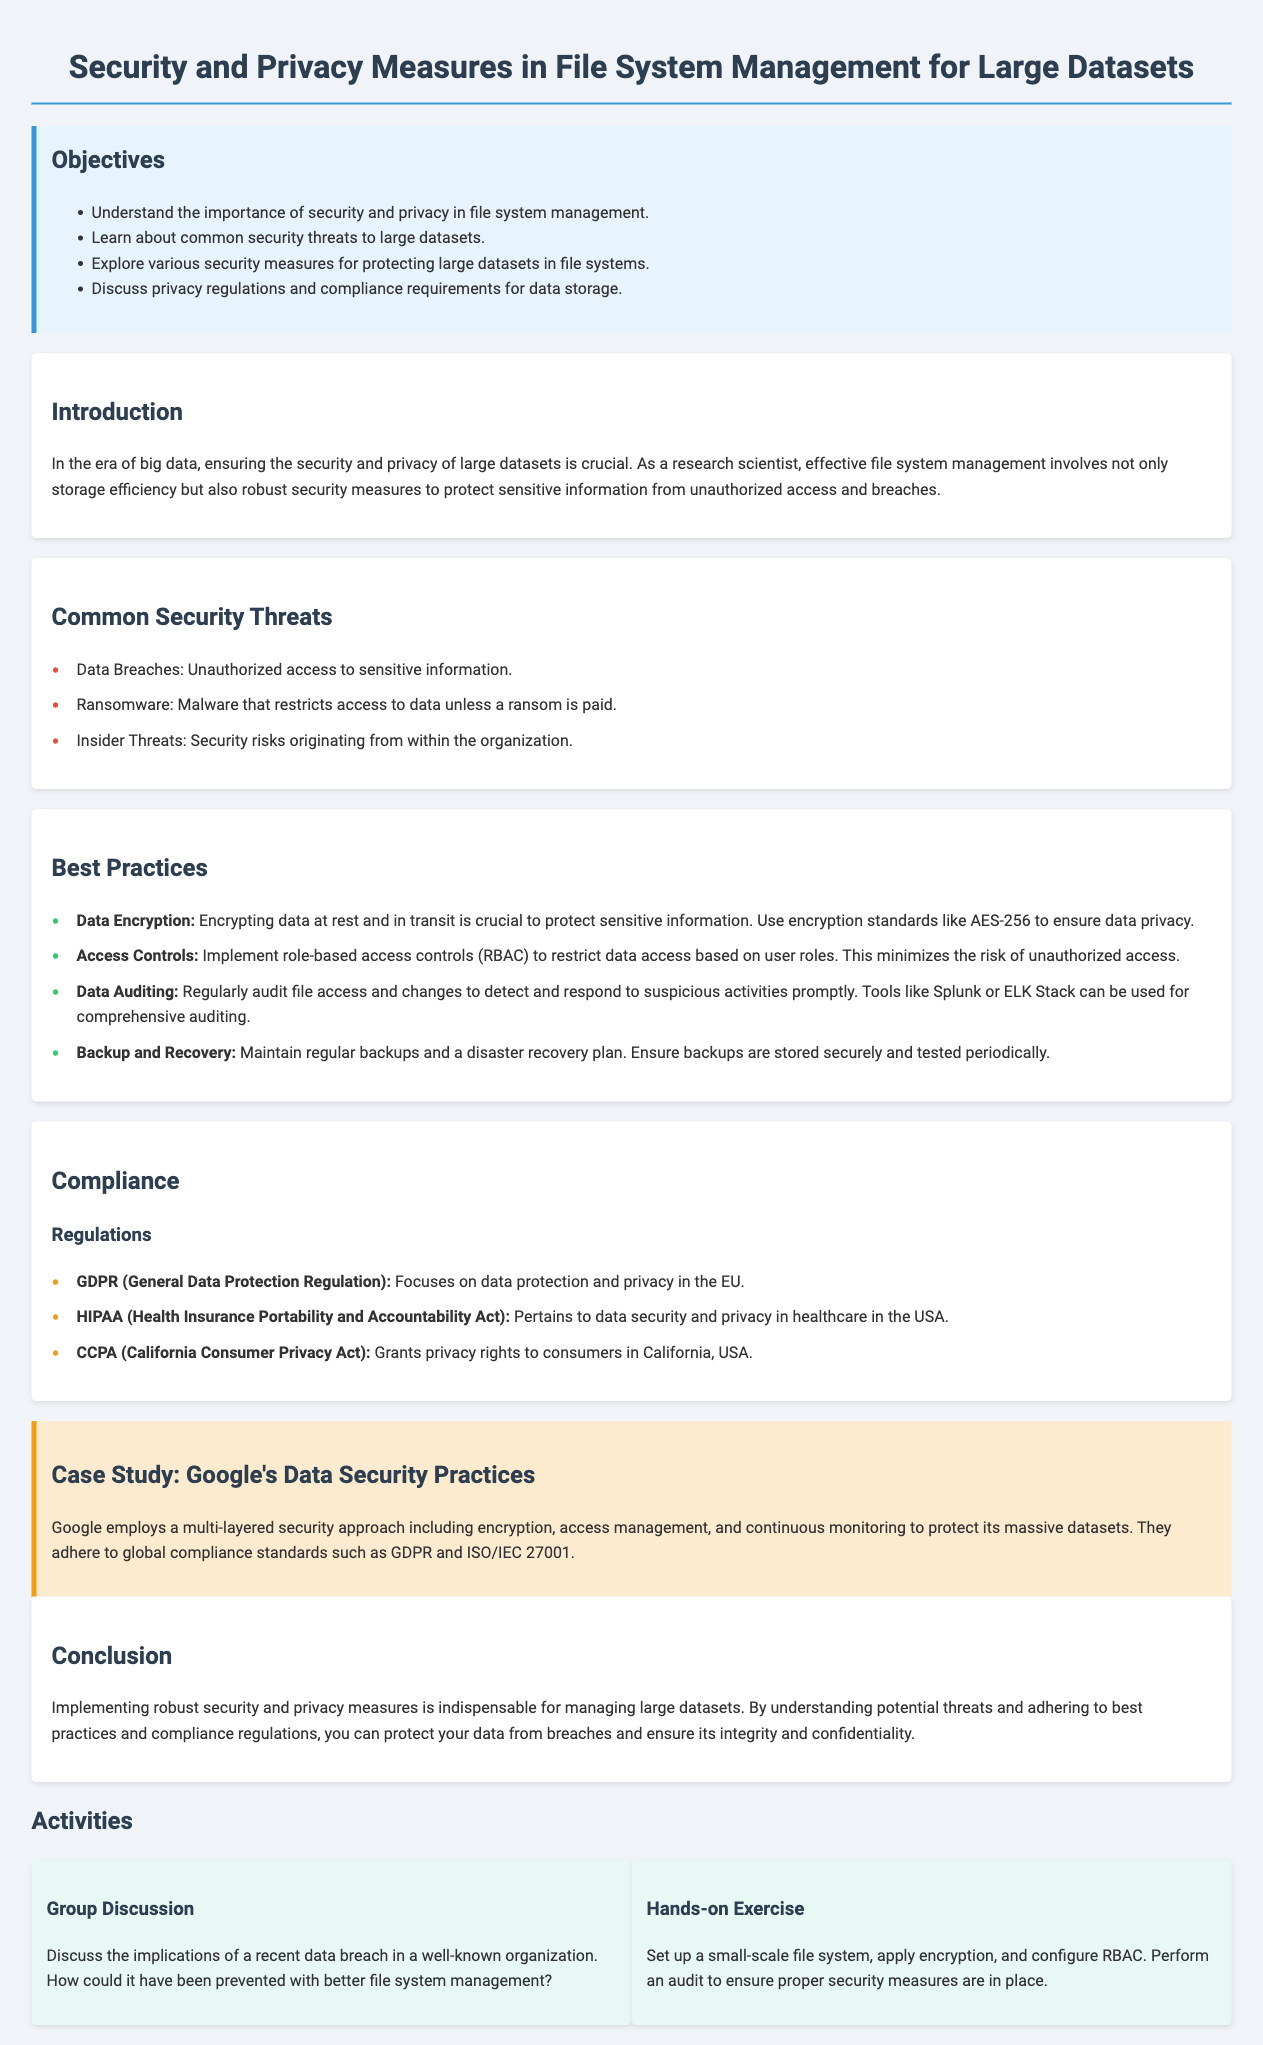What are the objectives of the lesson plan? The objectives are the specific goals outlined in the document for understanding security and privacy measures in file system management.
Answer: Understand the importance of security and privacy in file system management, learn about common security threats to large datasets, explore various security measures for protecting large datasets in file systems, discuss privacy regulations and compliance requirements for data storage What is one common security threat mentioned? The document lists common security threats in a section, and one example is provided in that list.
Answer: Data Breaches What standard is suggested for data encryption? The document mentions encryption standards in the best practices section, specifying a particular standard for protecting sensitive information.
Answer: AES-256 Which regulation is focused on data protection and privacy in the EU? The document discusses specific regulations in the compliance section, with GDPR being one of the key regulations mentioned.
Answer: GDPR What practice involves regularly auditing file access? This refers to one of the best practices outlined for managing security and privacy, indicating the importance of monitoring to detect suspicious activities.
Answer: Data Auditing What type of exercise involves setting up a file system? This question pertains to the activities section of the lesson plan, where a hands-on exercise is described that allows participants to engage practically with security measures.
Answer: Hands-on Exercise What case study is mentioned to illustrate data security practices? A specific company's name is provided in the case study section, showing a real-world application of the concepts discussed in the lesson.
Answer: Google What is a risk from within the organization? The document outlines various security threats, including one that specifically relates to risks stemming from individuals inside an organization.
Answer: Insider Threats What is the main focus of the conclusion? The conclusion summarizes the key takeaways of the lesson plan, emphasizing the importance of measures discussed throughout the document.
Answer: Importance of robust security and privacy measures 